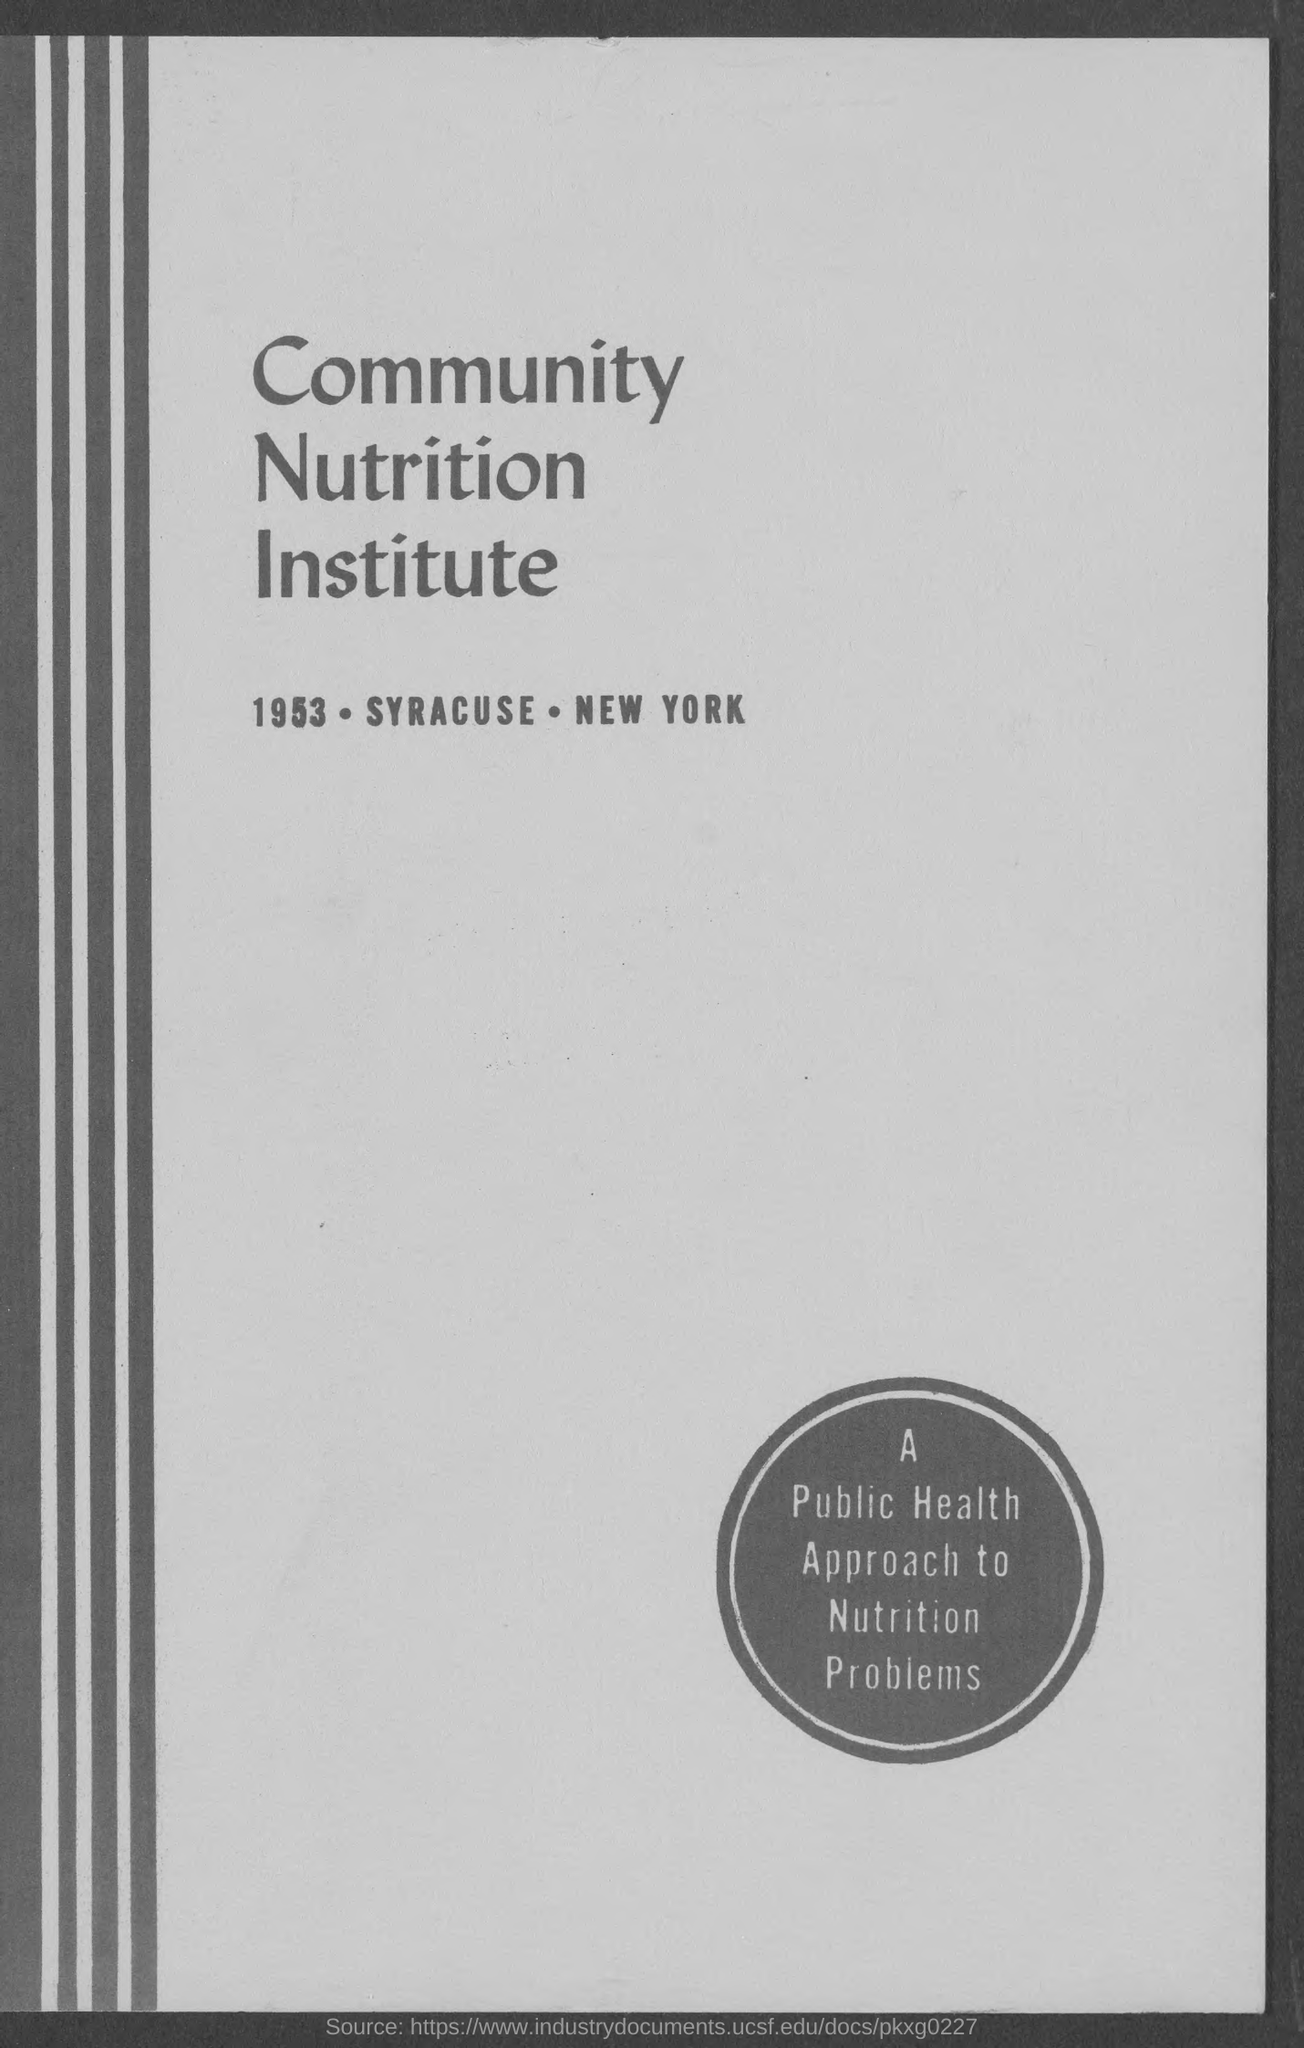What institute is mentioned?
Provide a succinct answer. Community nutrition institute. What is the year mentioned?
Ensure brevity in your answer.  1953. 